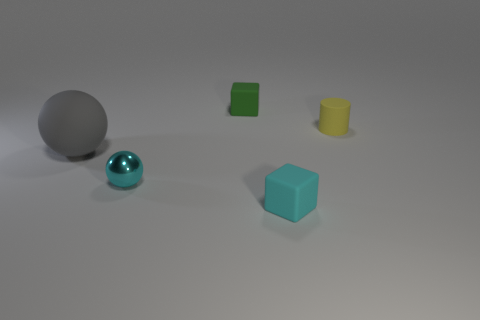Add 1 tiny green metal blocks. How many objects exist? 6 Subtract all spheres. How many objects are left? 3 Add 2 tiny yellow cylinders. How many tiny yellow cylinders are left? 3 Add 1 yellow matte cylinders. How many yellow matte cylinders exist? 2 Subtract 0 red cylinders. How many objects are left? 5 Subtract all matte cylinders. Subtract all cyan objects. How many objects are left? 2 